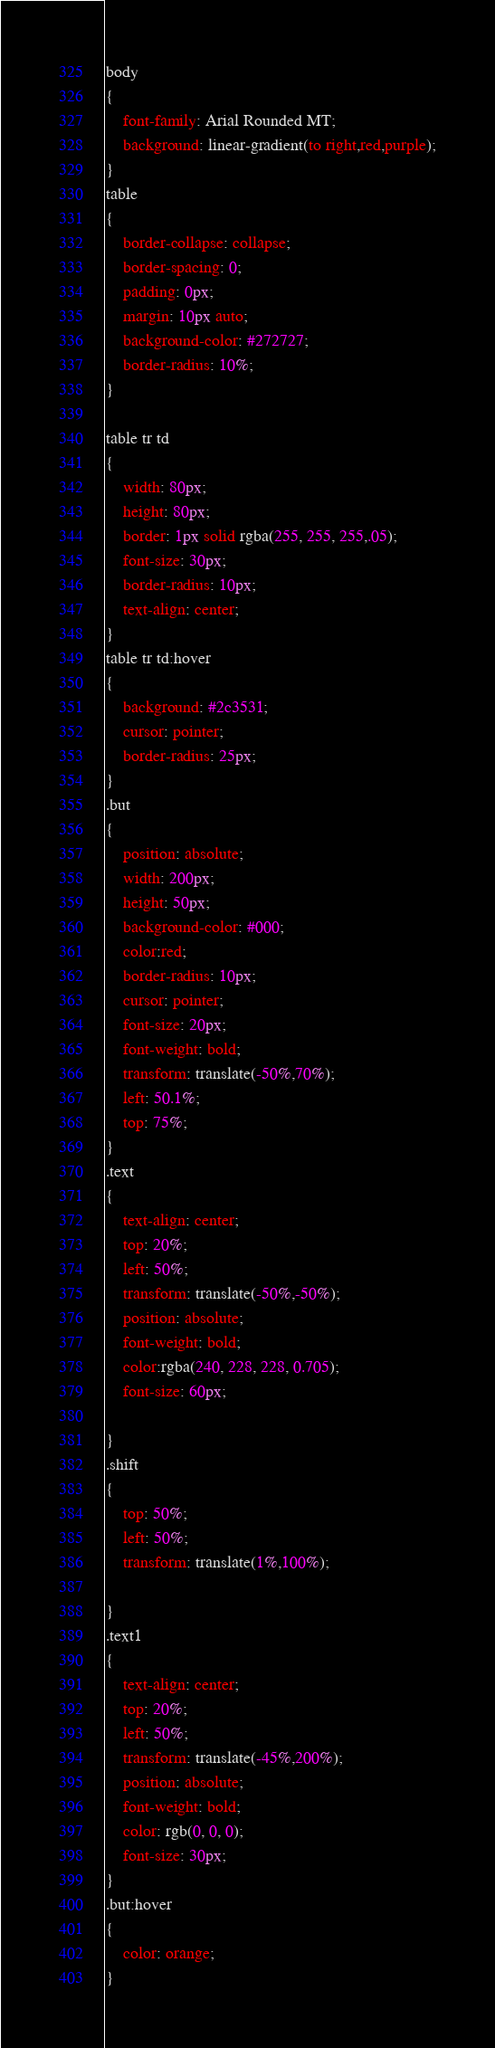Convert code to text. <code><loc_0><loc_0><loc_500><loc_500><_CSS_>body
{
    font-family: Arial Rounded MT;
    background: linear-gradient(to right,red,purple);
}
table
{
    border-collapse: collapse;
    border-spacing: 0;
    padding: 0px;
    margin: 10px auto;
    background-color: #272727;
    border-radius: 10%;
}

table tr td
{
    width: 80px;
    height: 80px;
    border: 1px solid rgba(255, 255, 255,.05);
    font-size: 30px;
    border-radius: 10px;
    text-align: center;
}
table tr td:hover
{
    background: #2c3531;
    cursor: pointer;
    border-radius: 25px;
}
.but
{
    position: absolute;
    width: 200px;
    height: 50px;
    background-color: #000;
    color:red;
    border-radius: 10px;
    cursor: pointer;
    font-size: 20px;
    font-weight: bold;
    transform: translate(-50%,70%);
    left: 50.1%;
    top: 75%;
}
.text
{
    text-align: center;
    top: 20%;
    left: 50%;
    transform: translate(-50%,-50%);
    position: absolute;
    font-weight: bold;
    color:rgba(240, 228, 228, 0.705);
    font-size: 60px;

}
.shift
{
    top: 50%;
    left: 50%;
    transform: translate(1%,100%);

}
.text1
{
    text-align: center;
    top: 20%;
    left: 50%;
    transform: translate(-45%,200%);
    position: absolute;
    font-weight: bold;
    color: rgb(0, 0, 0);
    font-size: 30px;
}
.but:hover
{
    color: orange;
}
</code> 